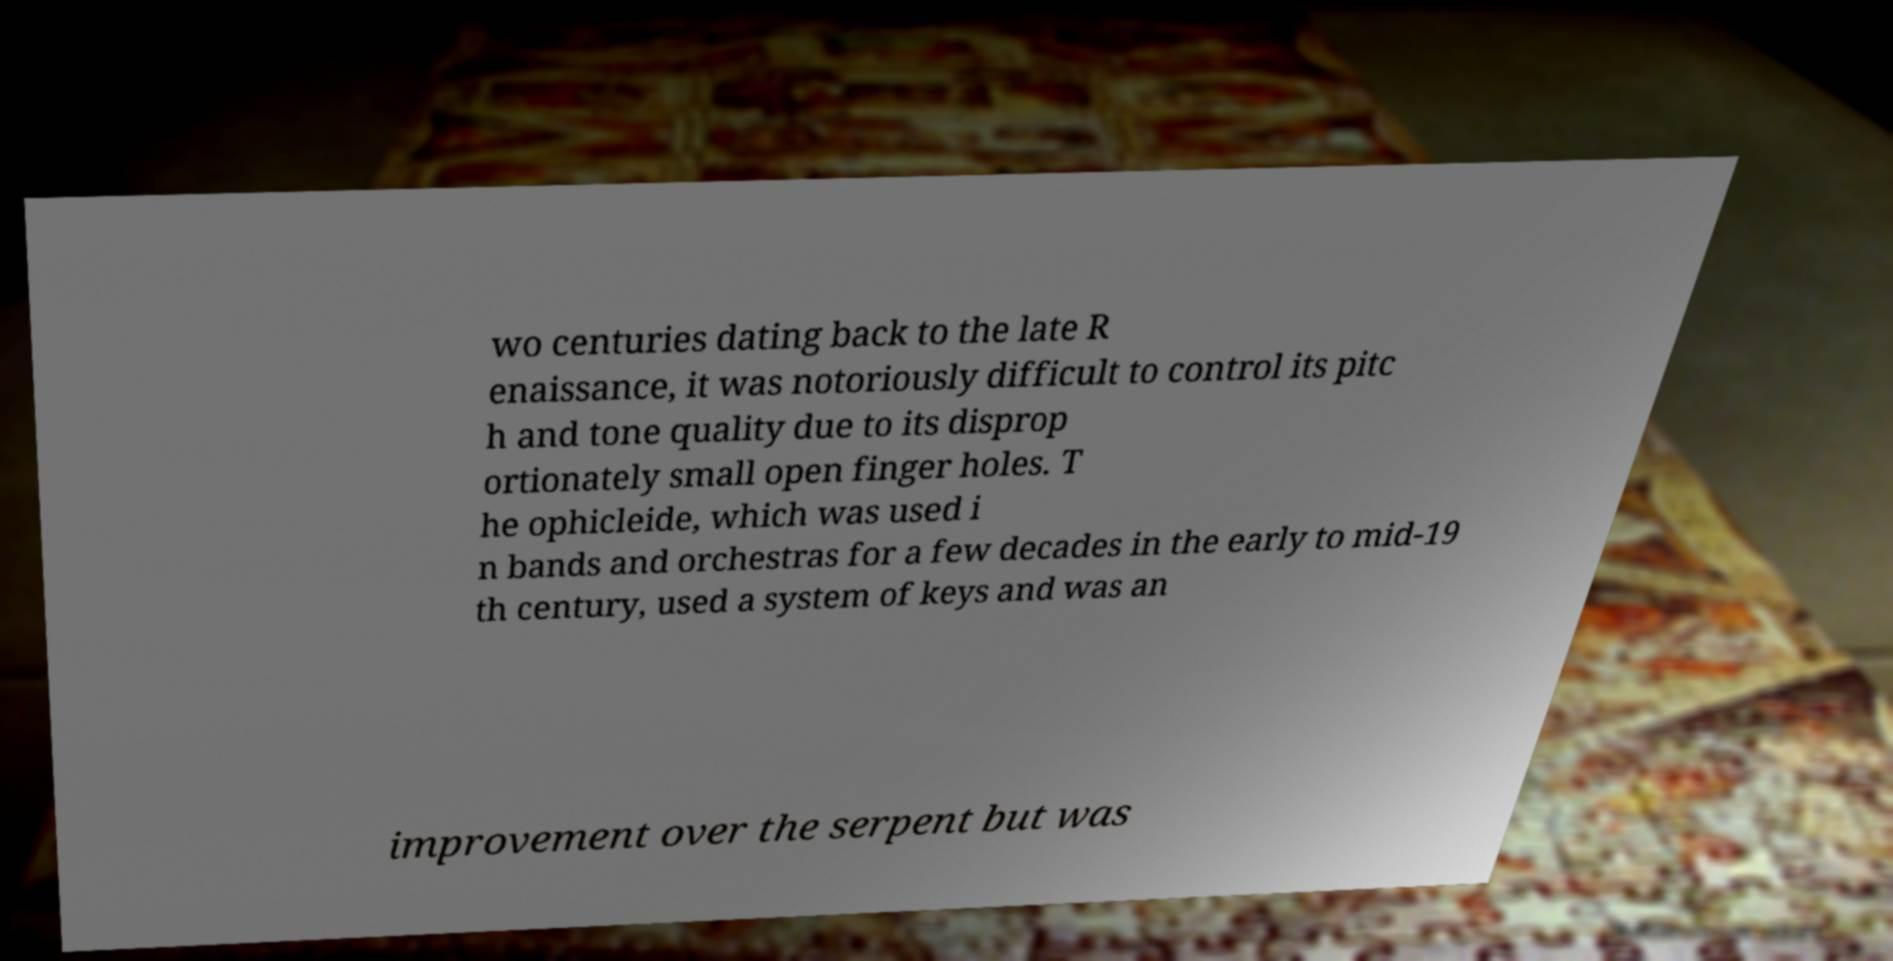For documentation purposes, I need the text within this image transcribed. Could you provide that? wo centuries dating back to the late R enaissance, it was notoriously difficult to control its pitc h and tone quality due to its disprop ortionately small open finger holes. T he ophicleide, which was used i n bands and orchestras for a few decades in the early to mid-19 th century, used a system of keys and was an improvement over the serpent but was 